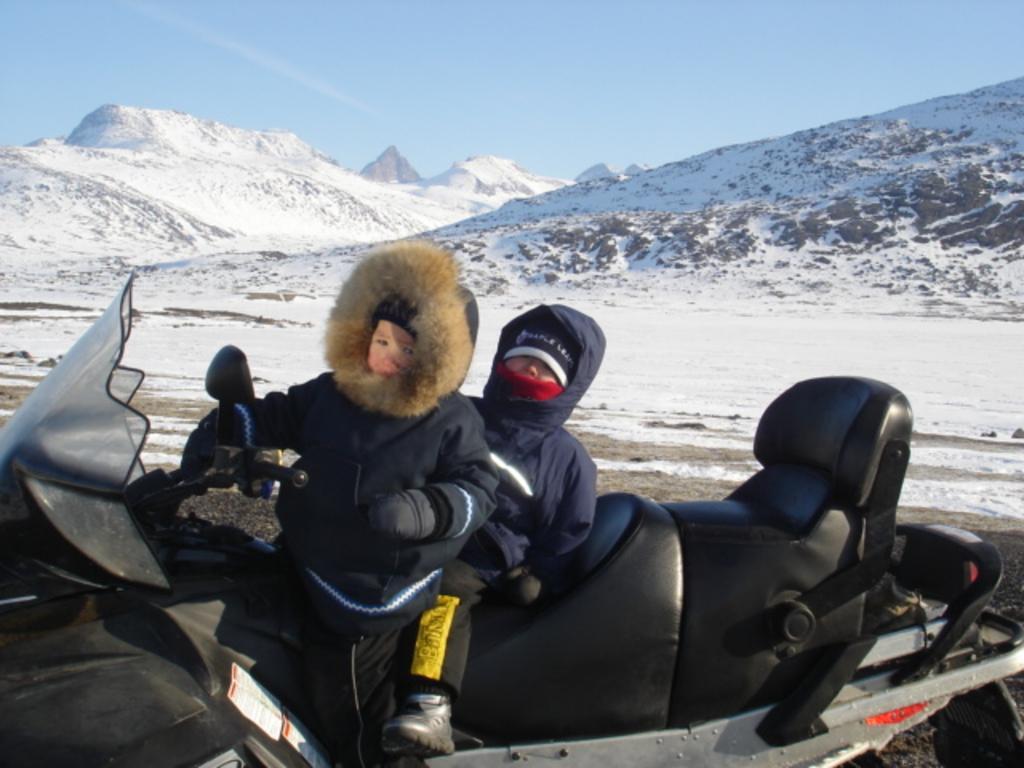Could you give a brief overview of what you see in this image? There are two persons on the vehicle. This is snow. In the background we can see mountain and sky. 